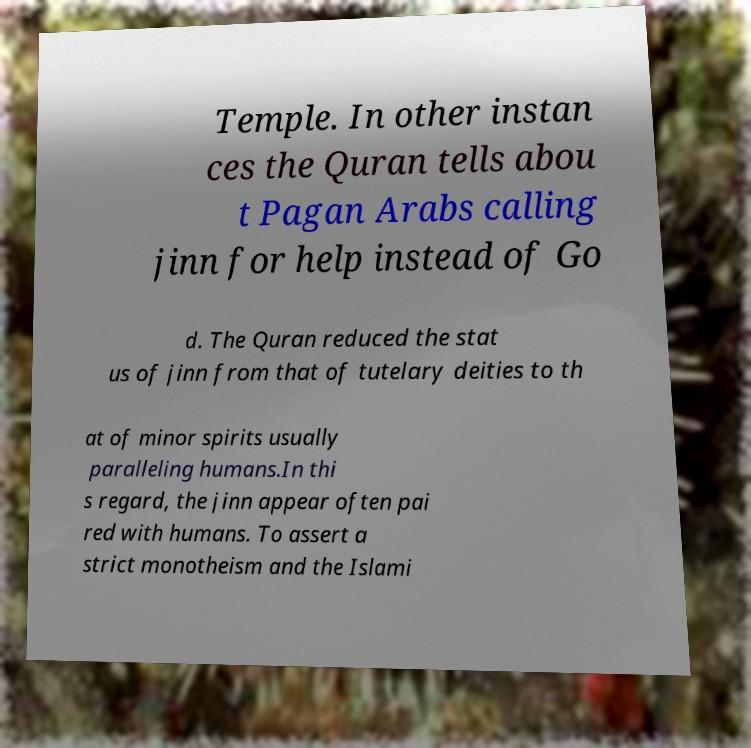What messages or text are displayed in this image? I need them in a readable, typed format. Temple. In other instan ces the Quran tells abou t Pagan Arabs calling jinn for help instead of Go d. The Quran reduced the stat us of jinn from that of tutelary deities to th at of minor spirits usually paralleling humans.In thi s regard, the jinn appear often pai red with humans. To assert a strict monotheism and the Islami 